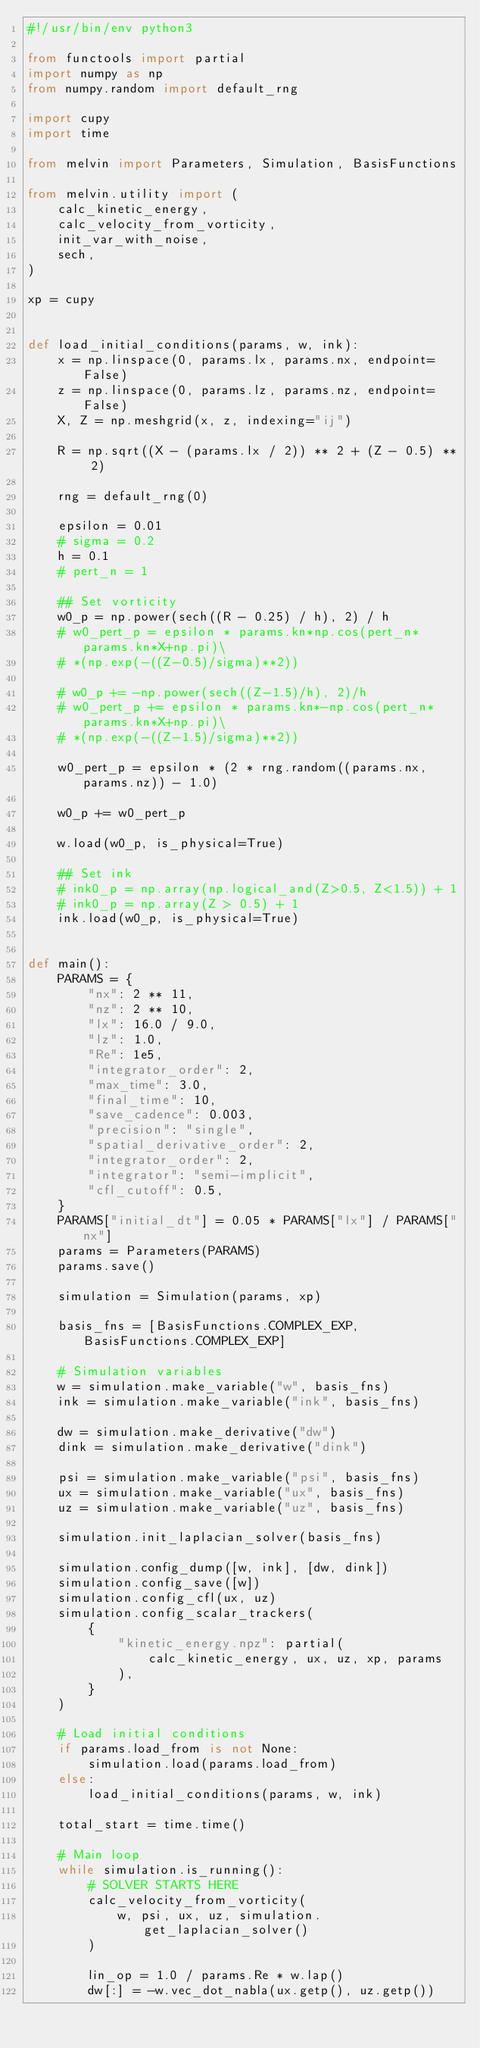Convert code to text. <code><loc_0><loc_0><loc_500><loc_500><_Python_>#!/usr/bin/env python3

from functools import partial
import numpy as np
from numpy.random import default_rng

import cupy
import time

from melvin import Parameters, Simulation, BasisFunctions

from melvin.utility import (
    calc_kinetic_energy,
    calc_velocity_from_vorticity,
    init_var_with_noise,
    sech,
)

xp = cupy


def load_initial_conditions(params, w, ink):
    x = np.linspace(0, params.lx, params.nx, endpoint=False)
    z = np.linspace(0, params.lz, params.nz, endpoint=False)
    X, Z = np.meshgrid(x, z, indexing="ij")

    R = np.sqrt((X - (params.lx / 2)) ** 2 + (Z - 0.5) ** 2)

    rng = default_rng(0)

    epsilon = 0.01
    # sigma = 0.2
    h = 0.1
    # pert_n = 1

    ## Set vorticity
    w0_p = np.power(sech((R - 0.25) / h), 2) / h
    # w0_pert_p = epsilon * params.kn*np.cos(pert_n*params.kn*X+np.pi)\
    # *(np.exp(-((Z-0.5)/sigma)**2))

    # w0_p += -np.power(sech((Z-1.5)/h), 2)/h
    # w0_pert_p += epsilon * params.kn*-np.cos(pert_n*params.kn*X+np.pi)\
    # *(np.exp(-((Z-1.5)/sigma)**2))

    w0_pert_p = epsilon * (2 * rng.random((params.nx, params.nz)) - 1.0)

    w0_p += w0_pert_p

    w.load(w0_p, is_physical=True)

    ## Set ink
    # ink0_p = np.array(np.logical_and(Z>0.5, Z<1.5)) + 1
    # ink0_p = np.array(Z > 0.5) + 1
    ink.load(w0_p, is_physical=True)


def main():
    PARAMS = {
        "nx": 2 ** 11,
        "nz": 2 ** 10,
        "lx": 16.0 / 9.0,
        "lz": 1.0,
        "Re": 1e5,
        "integrator_order": 2,
        "max_time": 3.0,
        "final_time": 10,
        "save_cadence": 0.003,
        "precision": "single",
        "spatial_derivative_order": 2,
        "integrator_order": 2,
        "integrator": "semi-implicit",
        "cfl_cutoff": 0.5,
    }
    PARAMS["initial_dt"] = 0.05 * PARAMS["lx"] / PARAMS["nx"]
    params = Parameters(PARAMS)
    params.save()

    simulation = Simulation(params, xp)

    basis_fns = [BasisFunctions.COMPLEX_EXP, BasisFunctions.COMPLEX_EXP]

    # Simulation variables
    w = simulation.make_variable("w", basis_fns)
    ink = simulation.make_variable("ink", basis_fns)

    dw = simulation.make_derivative("dw")
    dink = simulation.make_derivative("dink")

    psi = simulation.make_variable("psi", basis_fns)
    ux = simulation.make_variable("ux", basis_fns)
    uz = simulation.make_variable("uz", basis_fns)

    simulation.init_laplacian_solver(basis_fns)

    simulation.config_dump([w, ink], [dw, dink])
    simulation.config_save([w])
    simulation.config_cfl(ux, uz)
    simulation.config_scalar_trackers(
        {
            "kinetic_energy.npz": partial(
                calc_kinetic_energy, ux, uz, xp, params
            ),
        }
    )

    # Load initial conditions
    if params.load_from is not None:
        simulation.load(params.load_from)
    else:
        load_initial_conditions(params, w, ink)

    total_start = time.time()

    # Main loop
    while simulation.is_running():
        # SOLVER STARTS HERE
        calc_velocity_from_vorticity(
            w, psi, ux, uz, simulation.get_laplacian_solver()
        )

        lin_op = 1.0 / params.Re * w.lap()
        dw[:] = -w.vec_dot_nabla(ux.getp(), uz.getp())</code> 